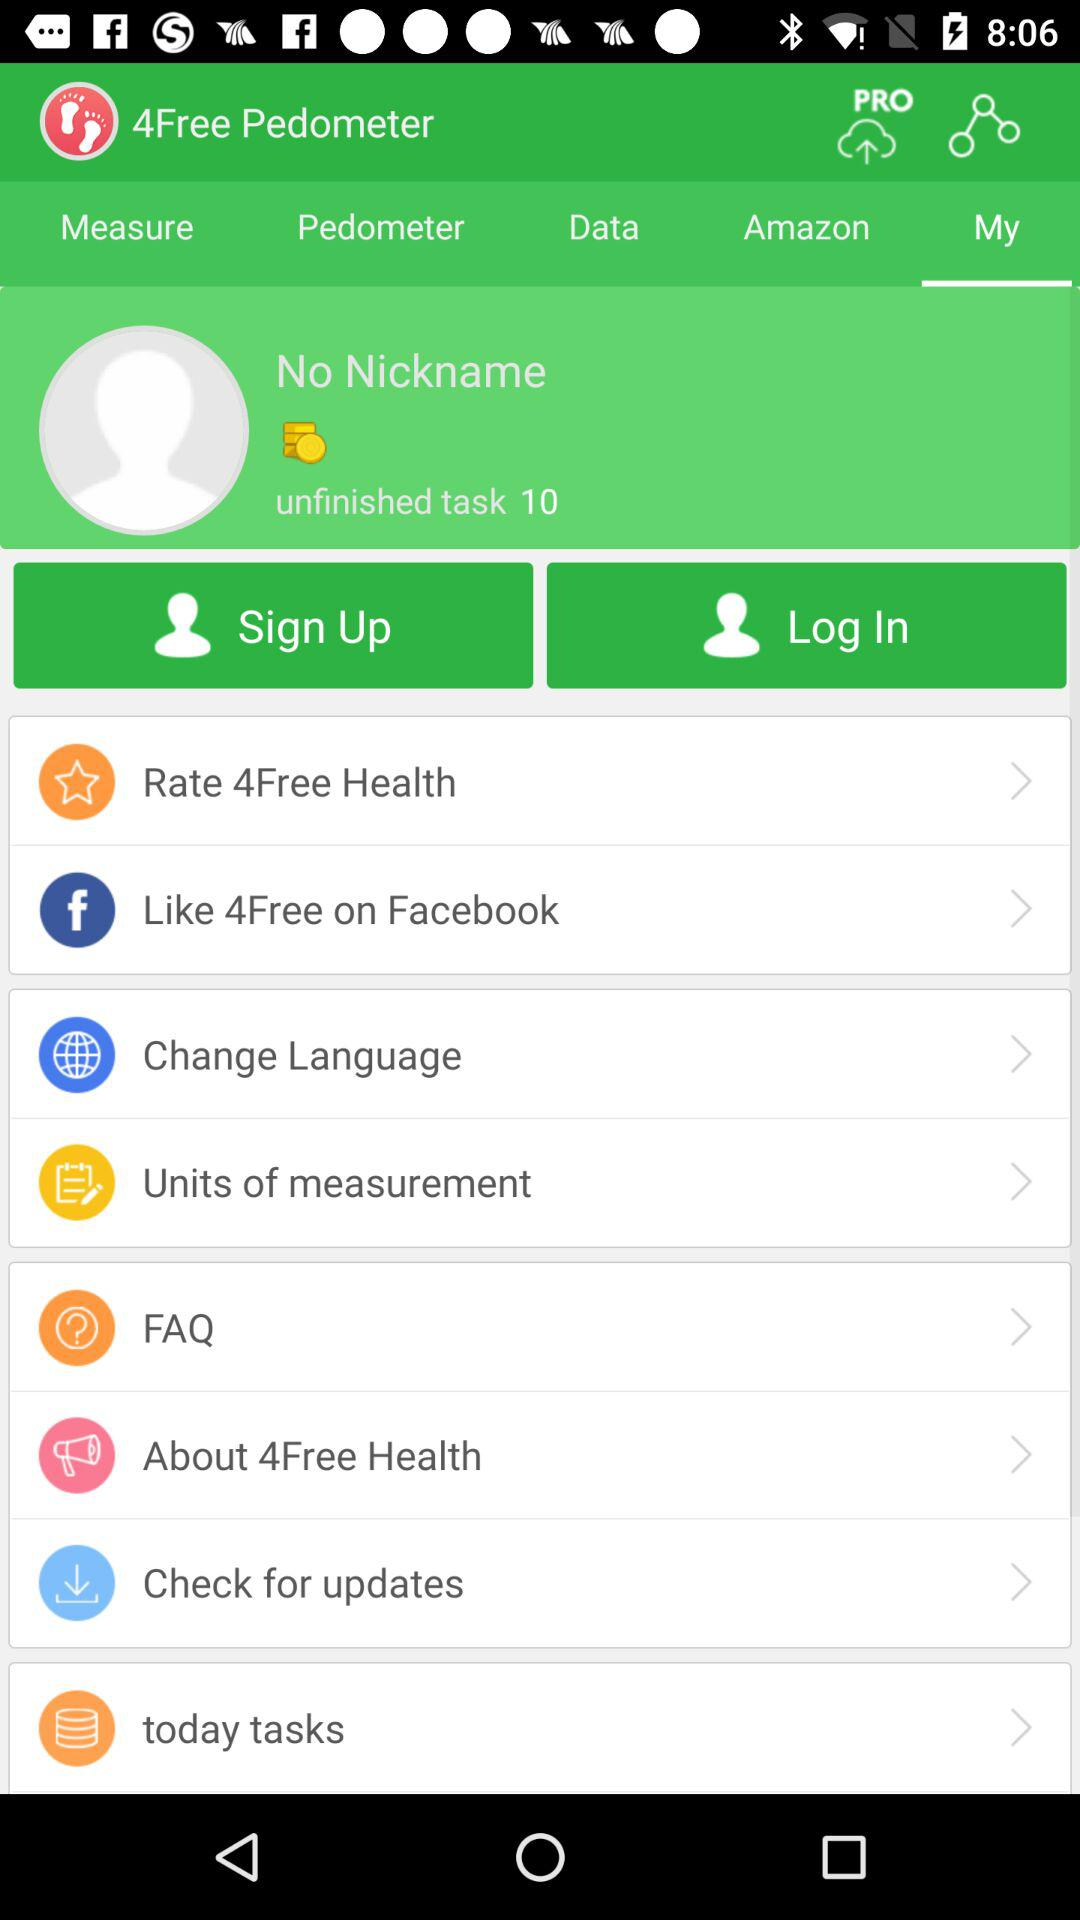What is the name of the application? The name of the application is "4Free Pedometer". 